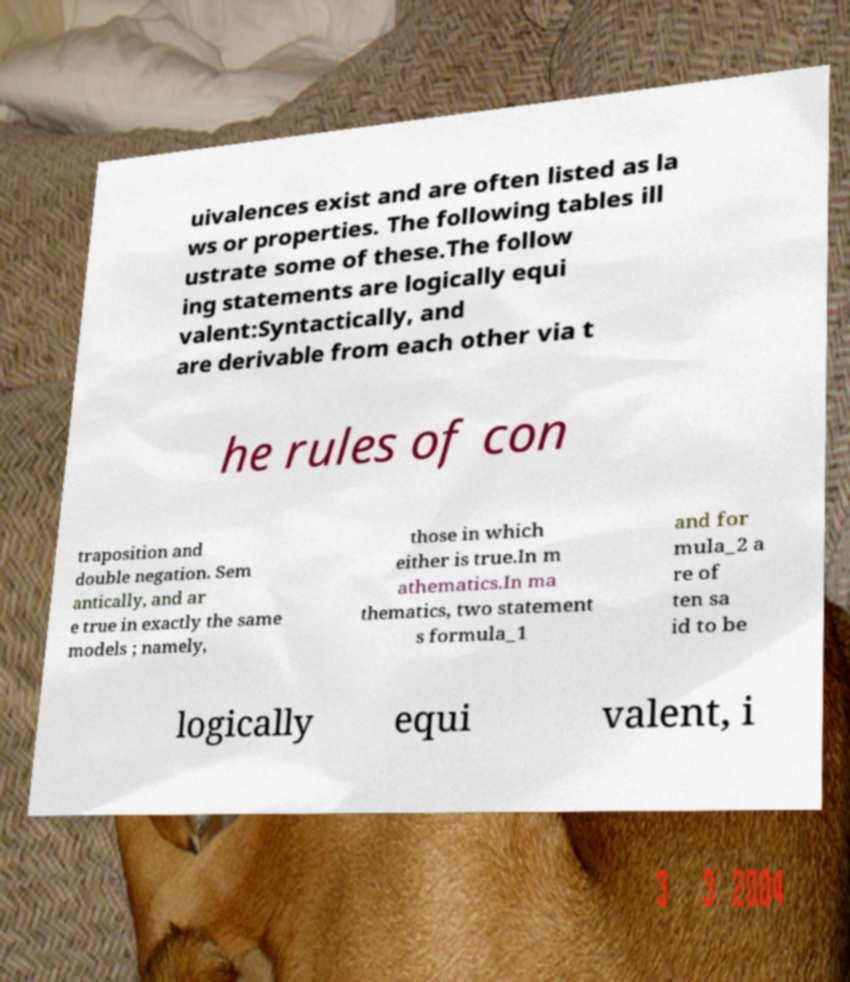Could you assist in decoding the text presented in this image and type it out clearly? uivalences exist and are often listed as la ws or properties. The following tables ill ustrate some of these.The follow ing statements are logically equi valent:Syntactically, and are derivable from each other via t he rules of con traposition and double negation. Sem antically, and ar e true in exactly the same models ; namely, those in which either is true.In m athematics.In ma thematics, two statement s formula_1 and for mula_2 a re of ten sa id to be logically equi valent, i 